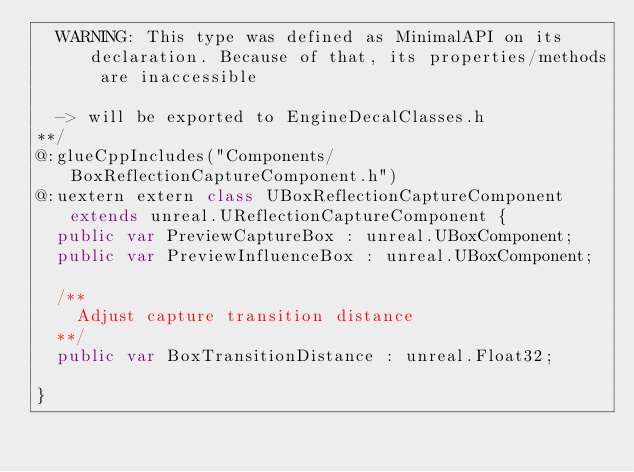<code> <loc_0><loc_0><loc_500><loc_500><_Haxe_>  WARNING: This type was defined as MinimalAPI on its declaration. Because of that, its properties/methods are inaccessible
  
  -> will be exported to EngineDecalClasses.h
**/
@:glueCppIncludes("Components/BoxReflectionCaptureComponent.h")
@:uextern extern class UBoxReflectionCaptureComponent extends unreal.UReflectionCaptureComponent {
  public var PreviewCaptureBox : unreal.UBoxComponent;
  public var PreviewInfluenceBox : unreal.UBoxComponent;
  
  /**
    Adjust capture transition distance
  **/
  public var BoxTransitionDistance : unreal.Float32;
  
}
</code> 